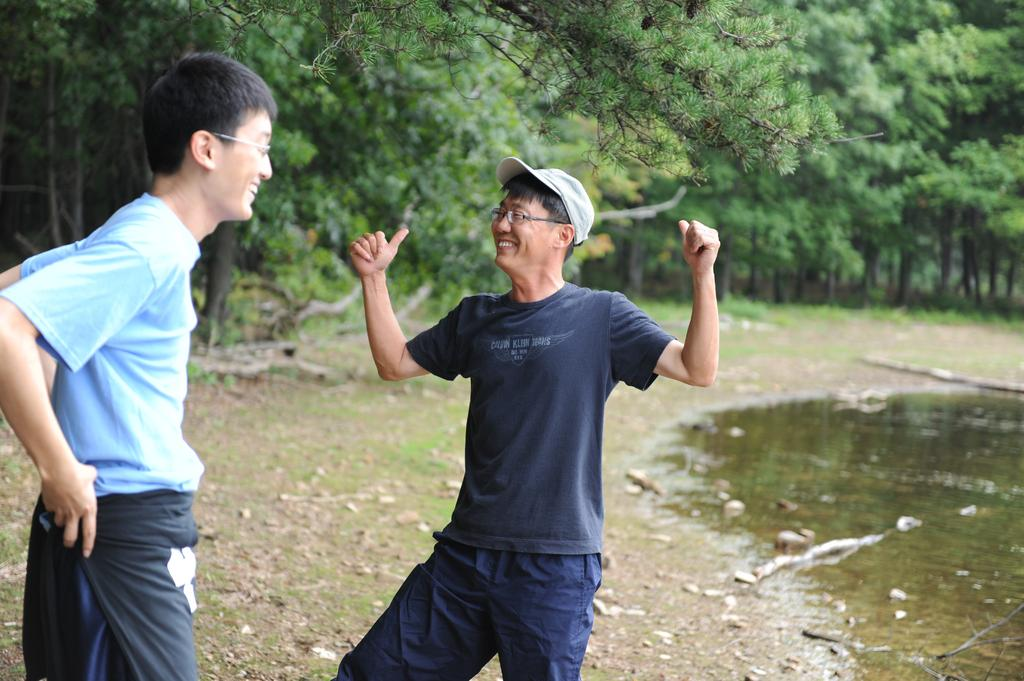How many people are in the image? There are two persons standing in the left corner of the image. What can be seen in the right corner of the image? There is water in the right corner of the image. What is visible in the background of the image? There are trees in the background of the image. What type of game are the two persons playing in the image? There is no game being played in the image; the two persons are simply standing in the left corner. 